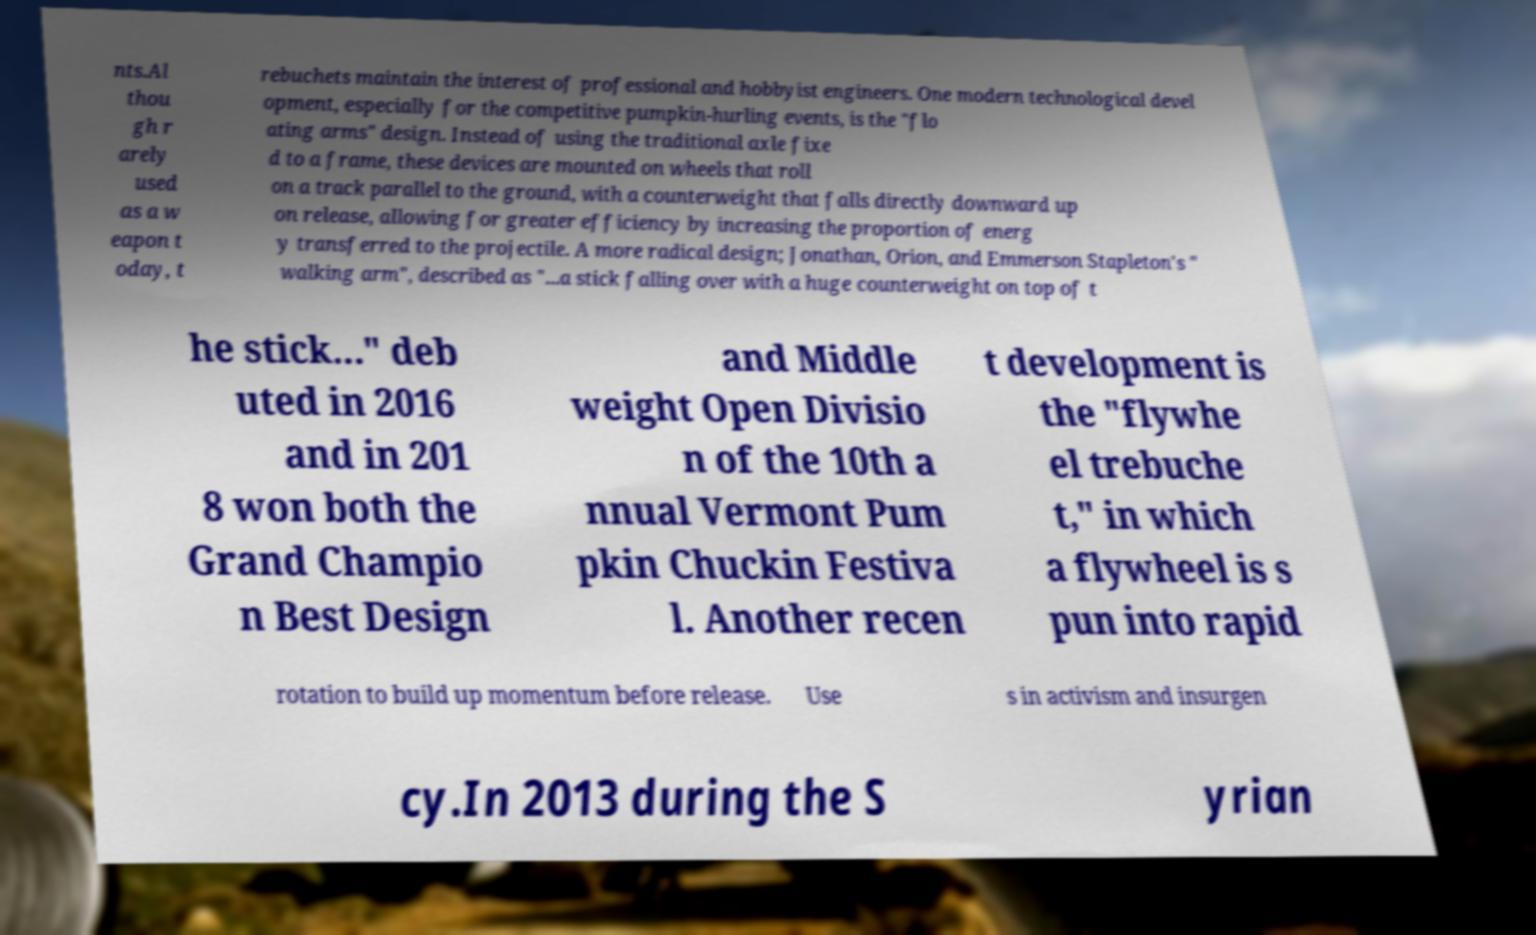Please read and relay the text visible in this image. What does it say? nts.Al thou gh r arely used as a w eapon t oday, t rebuchets maintain the interest of professional and hobbyist engineers. One modern technological devel opment, especially for the competitive pumpkin-hurling events, is the "flo ating arms" design. Instead of using the traditional axle fixe d to a frame, these devices are mounted on wheels that roll on a track parallel to the ground, with a counterweight that falls directly downward up on release, allowing for greater efficiency by increasing the proportion of energ y transferred to the projectile. A more radical design; Jonathan, Orion, and Emmerson Stapleton's " walking arm", described as "...a stick falling over with a huge counterweight on top of t he stick..." deb uted in 2016 and in 201 8 won both the Grand Champio n Best Design and Middle weight Open Divisio n of the 10th a nnual Vermont Pum pkin Chuckin Festiva l. Another recen t development is the "flywhe el trebuche t," in which a flywheel is s pun into rapid rotation to build up momentum before release. Use s in activism and insurgen cy.In 2013 during the S yrian 